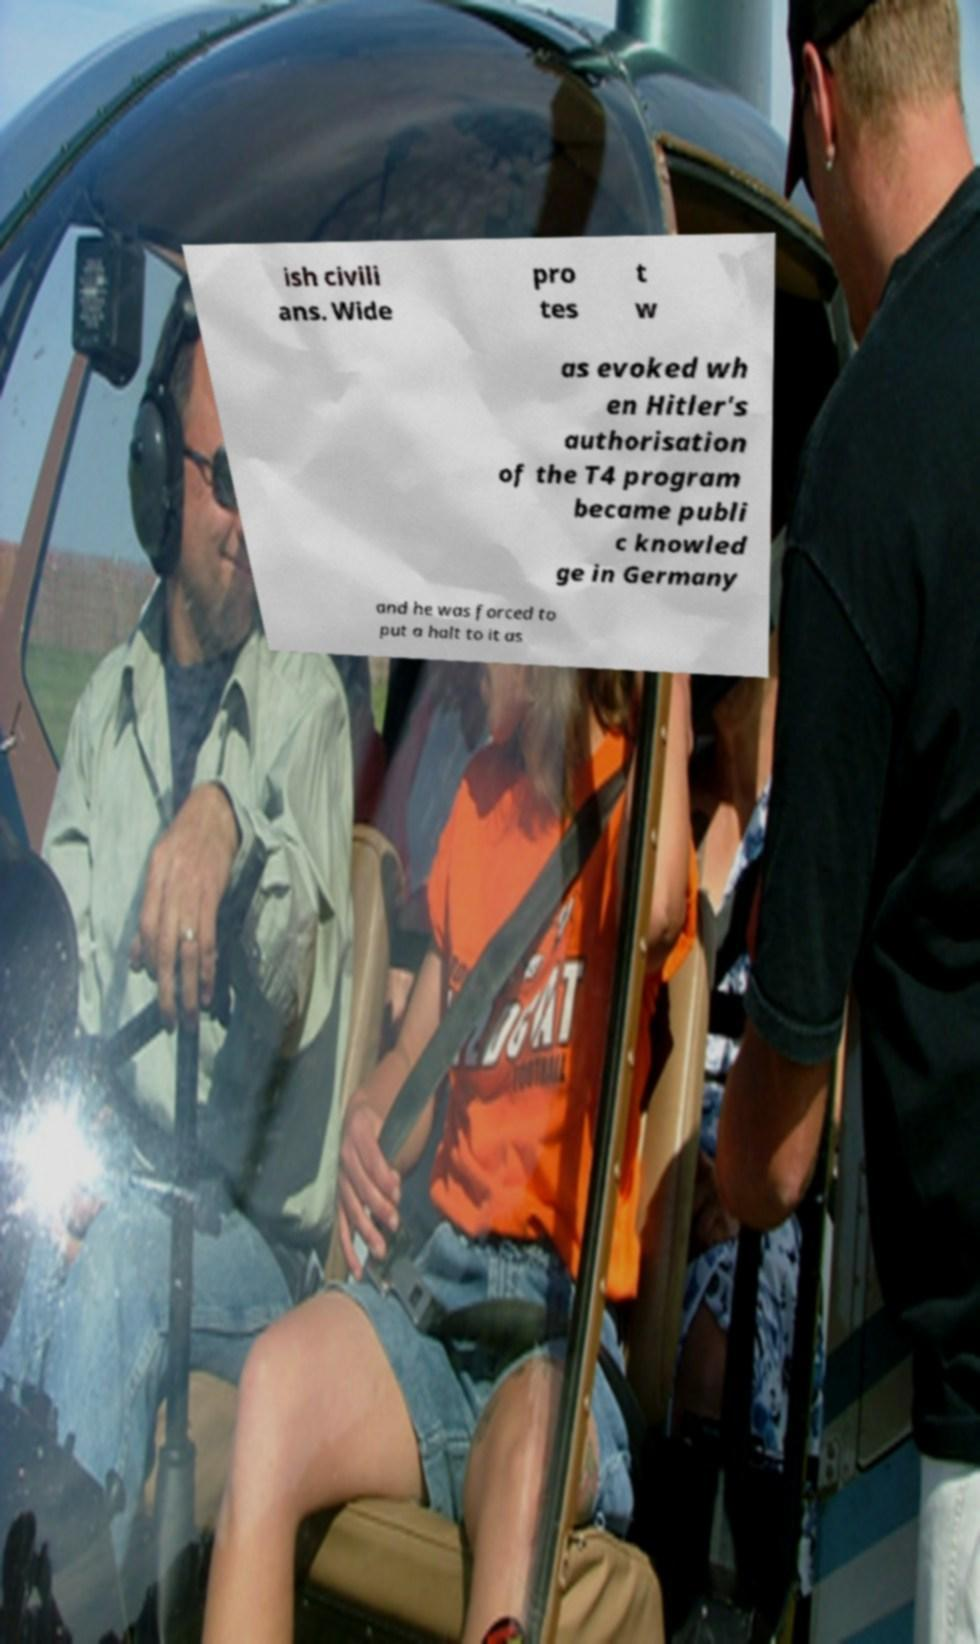I need the written content from this picture converted into text. Can you do that? ish civili ans. Wide pro tes t w as evoked wh en Hitler's authorisation of the T4 program became publi c knowled ge in Germany and he was forced to put a halt to it as 